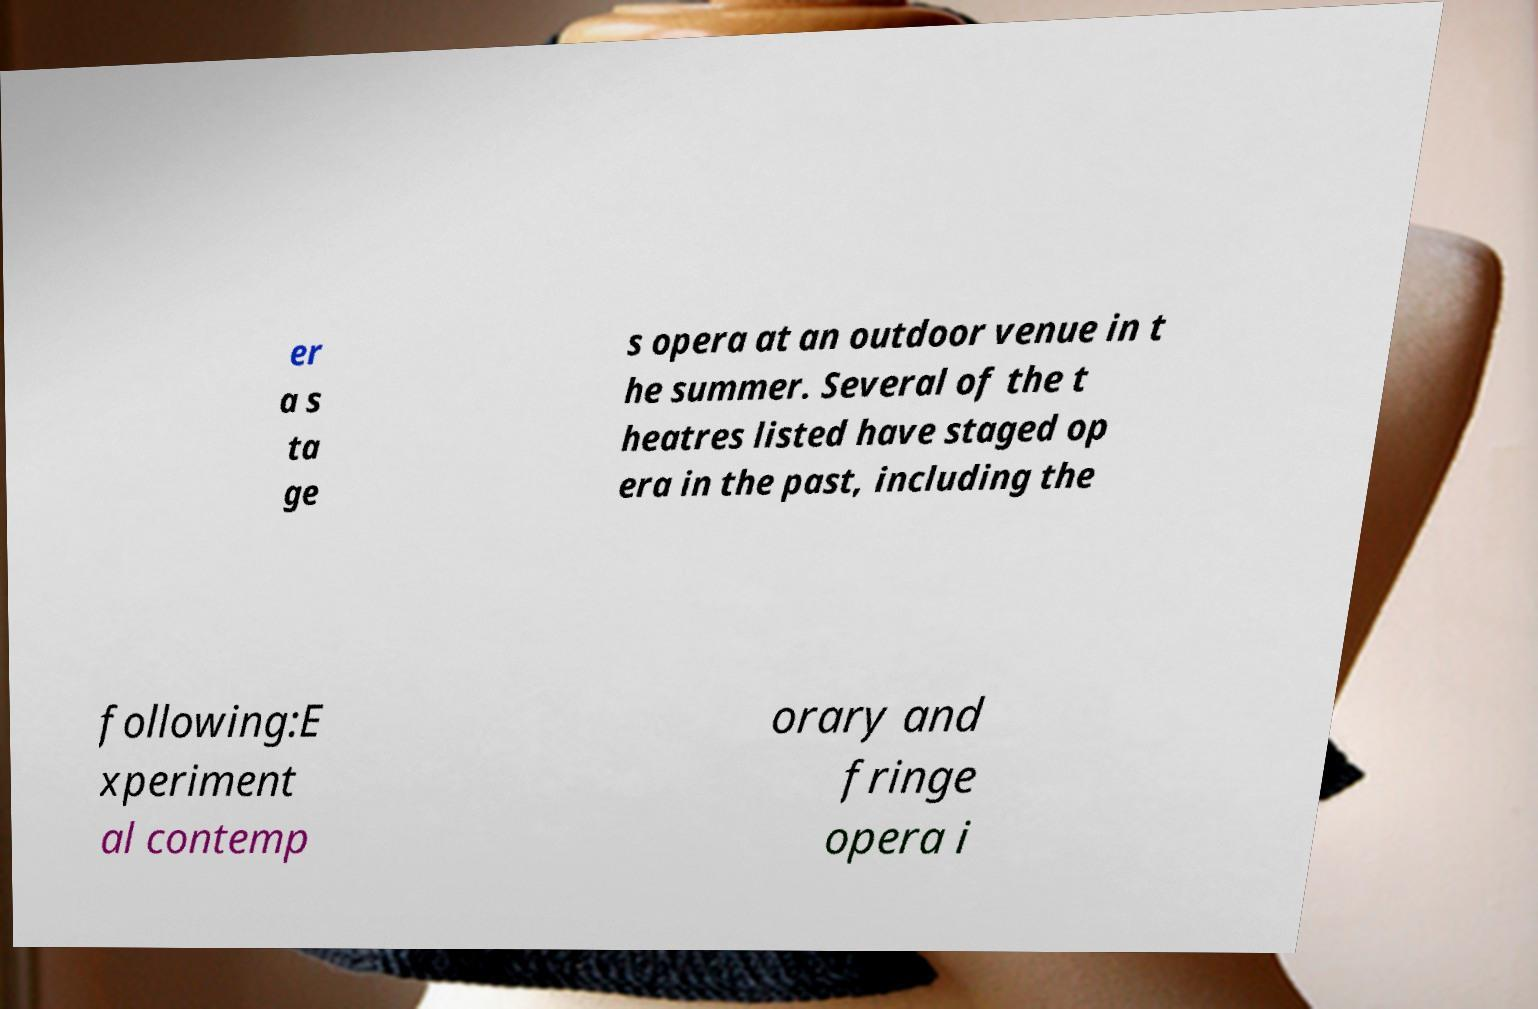For documentation purposes, I need the text within this image transcribed. Could you provide that? er a s ta ge s opera at an outdoor venue in t he summer. Several of the t heatres listed have staged op era in the past, including the following:E xperiment al contemp orary and fringe opera i 